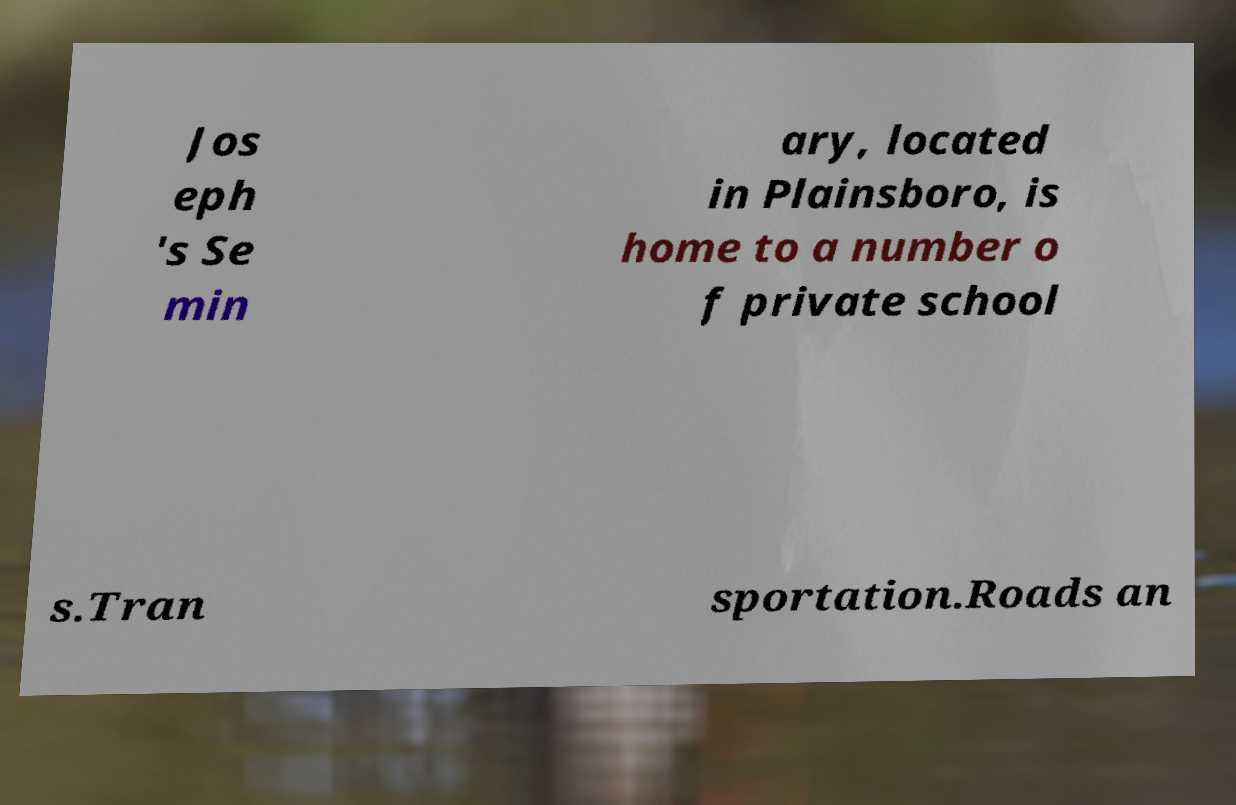Please read and relay the text visible in this image. What does it say? Jos eph 's Se min ary, located in Plainsboro, is home to a number o f private school s.Tran sportation.Roads an 